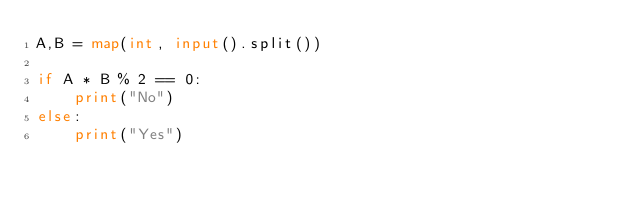Convert code to text. <code><loc_0><loc_0><loc_500><loc_500><_Python_>A,B = map(int, input().split())

if A * B % 2 == 0:
    print("No")
else:
    print("Yes")</code> 